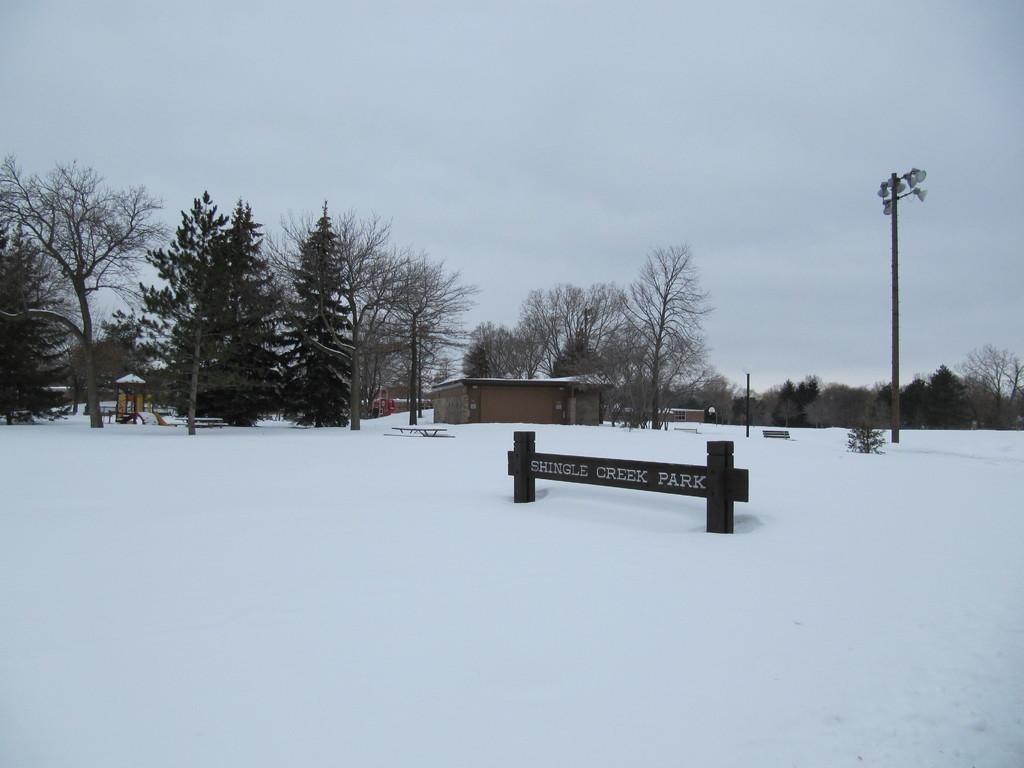What is covering the ground in the image? There is snow on the ground in the image. What type of natural elements can be seen in the image? There are trees in the image. What is located on the right side of the image? There is a pole on the right side of the image. What is visible in the background of the image? The sky is visible in the image. What is the condition of the sky in the image? The sky is cloudy in the image. What rhythm is the snow following as it falls in the image? There is no indication of snow falling in the image, and therefore no rhythm can be observed. 